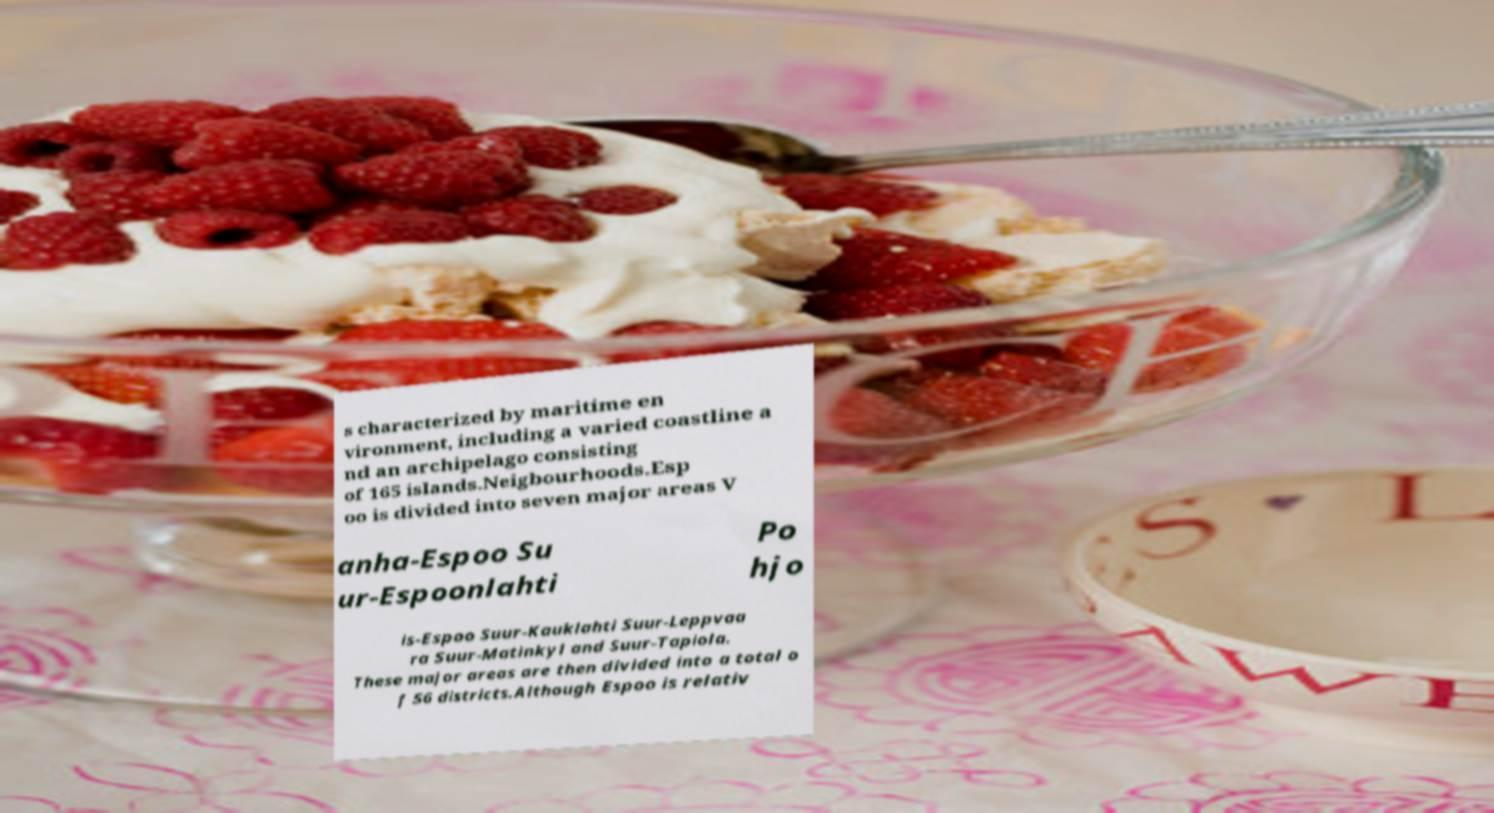Could you extract and type out the text from this image? s characterized by maritime en vironment, including a varied coastline a nd an archipelago consisting of 165 islands.Neigbourhoods.Esp oo is divided into seven major areas V anha-Espoo Su ur-Espoonlahti Po hjo is-Espoo Suur-Kauklahti Suur-Leppvaa ra Suur-Matinkyl and Suur-Tapiola. These major areas are then divided into a total o f 56 districts.Although Espoo is relativ 